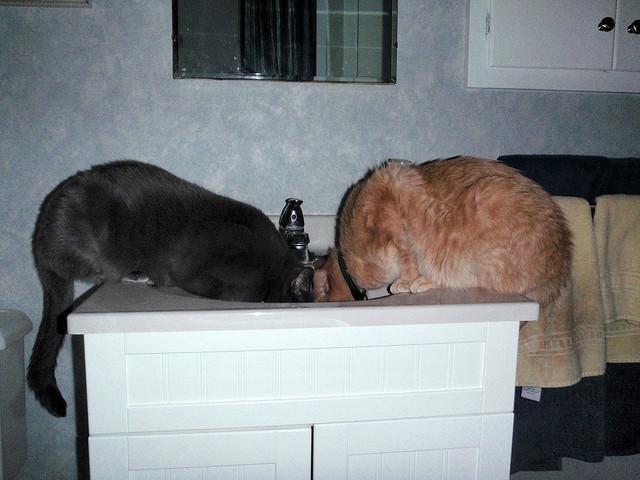What color is the sink?
Write a very short answer. White. Are the towels white?
Keep it brief. No. Are cats supposed to drink out of the sink?
Quick response, please. No. 